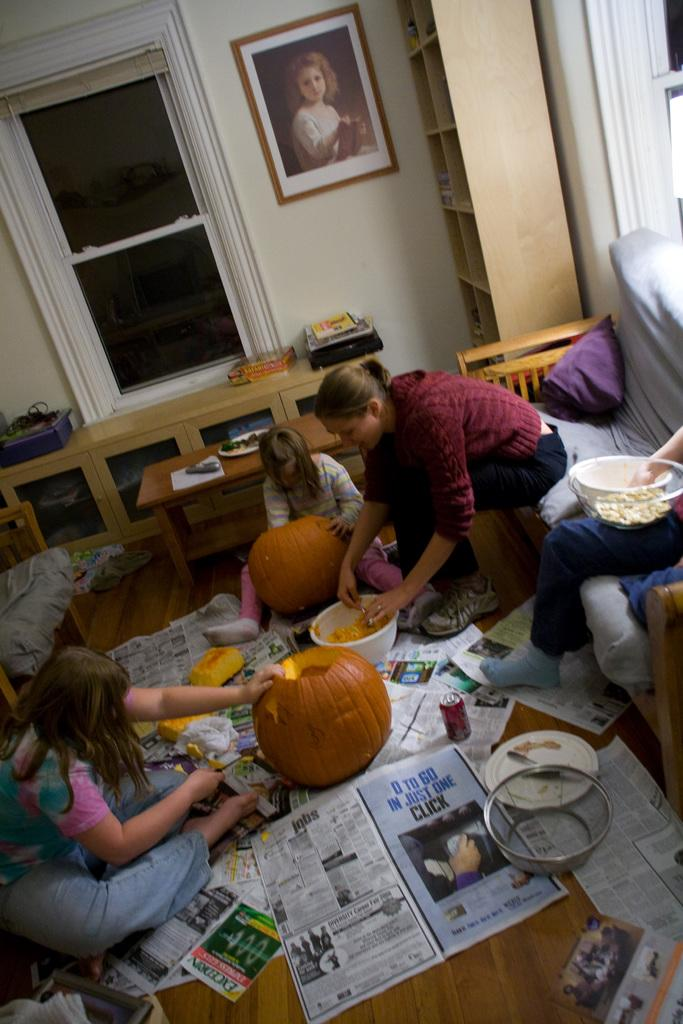How many people are in the image? There is a group of persons in the image. What are the persons in the image doing? The persons are doing some work. What can be seen in the background of the image? There is a painting on the wall in the background of the image. What type of soap is being used by the persons in the image? There is no soap present in the image; the persons are doing some work, but no soap is mentioned or visible. 